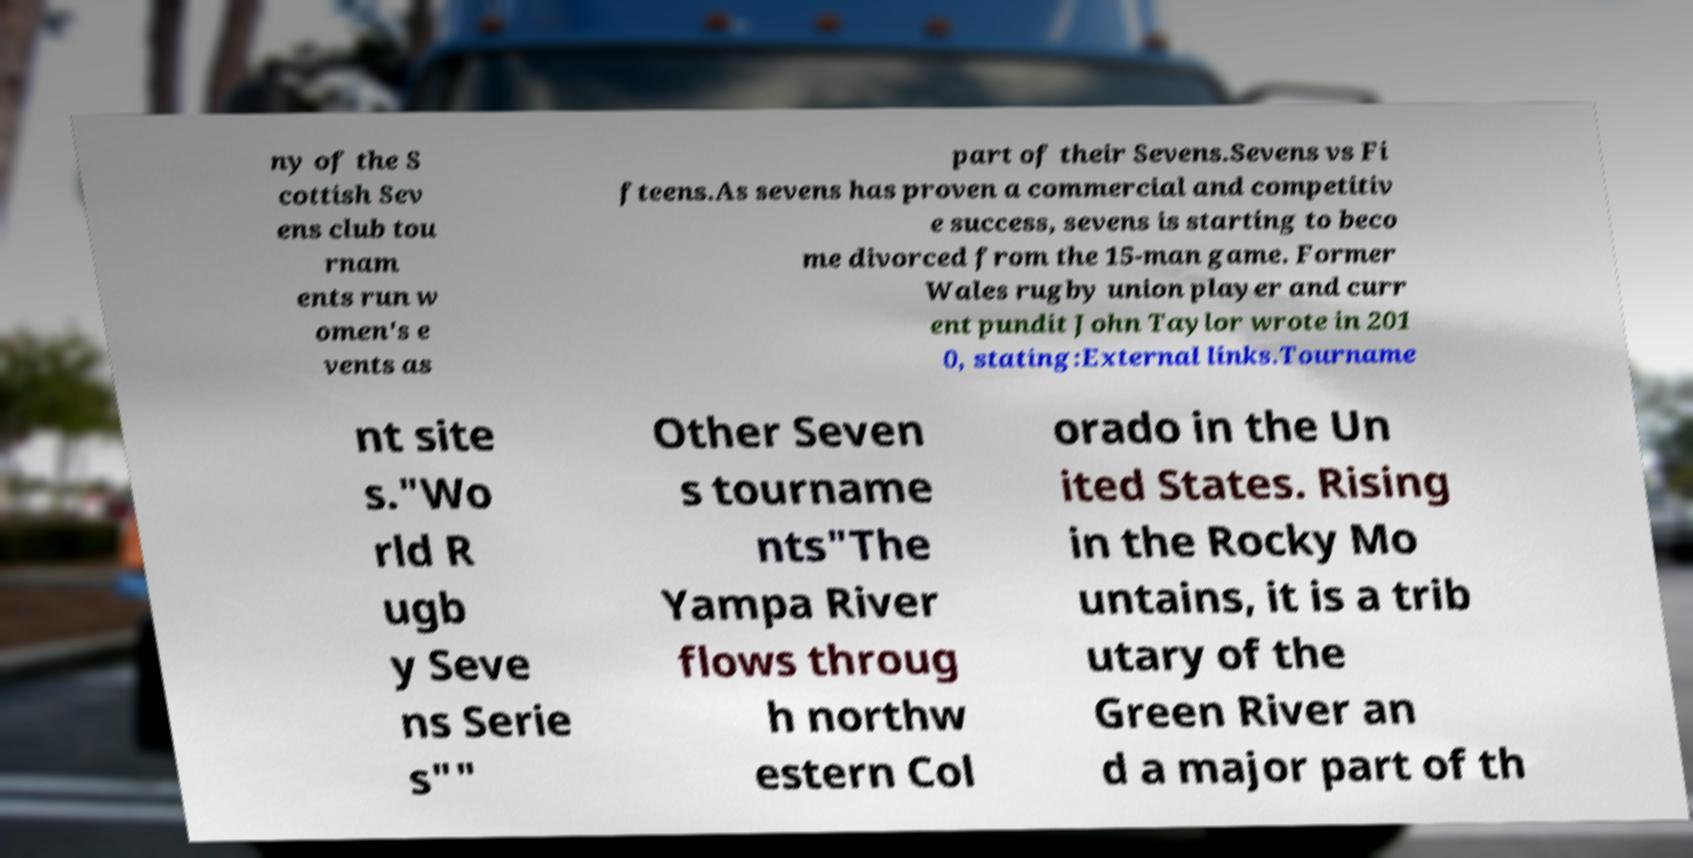Could you assist in decoding the text presented in this image and type it out clearly? ny of the S cottish Sev ens club tou rnam ents run w omen's e vents as part of their Sevens.Sevens vs Fi fteens.As sevens has proven a commercial and competitiv e success, sevens is starting to beco me divorced from the 15-man game. Former Wales rugby union player and curr ent pundit John Taylor wrote in 201 0, stating:External links.Tourname nt site s."Wo rld R ugb y Seve ns Serie s"" Other Seven s tourname nts"The Yampa River flows throug h northw estern Col orado in the Un ited States. Rising in the Rocky Mo untains, it is a trib utary of the Green River an d a major part of th 